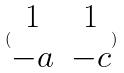<formula> <loc_0><loc_0><loc_500><loc_500>( \begin{matrix} 1 & 1 \\ - a & - c \end{matrix} )</formula> 